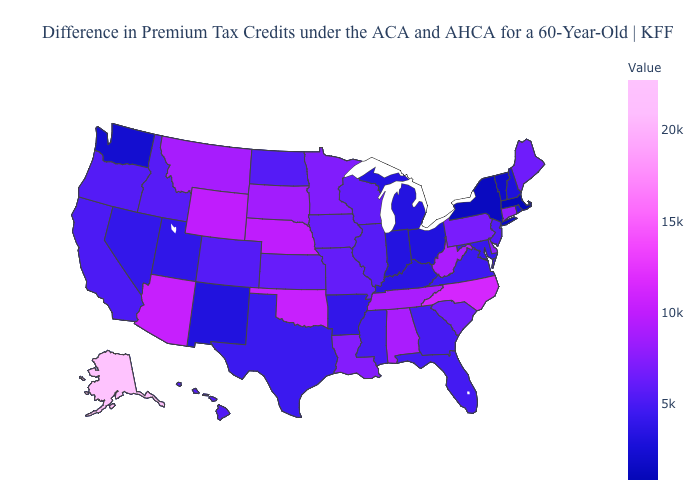Among the states that border Illinois , which have the highest value?
Give a very brief answer. Iowa. Which states have the lowest value in the USA?
Give a very brief answer. Massachusetts. Which states have the lowest value in the USA?
Quick response, please. Massachusetts. Which states have the highest value in the USA?
Keep it brief. Alaska. Does Indiana have a lower value than South Dakota?
Write a very short answer. Yes. Which states have the lowest value in the USA?
Give a very brief answer. Massachusetts. Does Wyoming have a lower value than Alaska?
Give a very brief answer. Yes. 